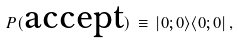Convert formula to latex. <formula><loc_0><loc_0><loc_500><loc_500>P ( \text {accept} ) \, \equiv \, | { 0 } ; { 0 } \rangle \langle { 0 } ; { 0 } | \, ,</formula> 